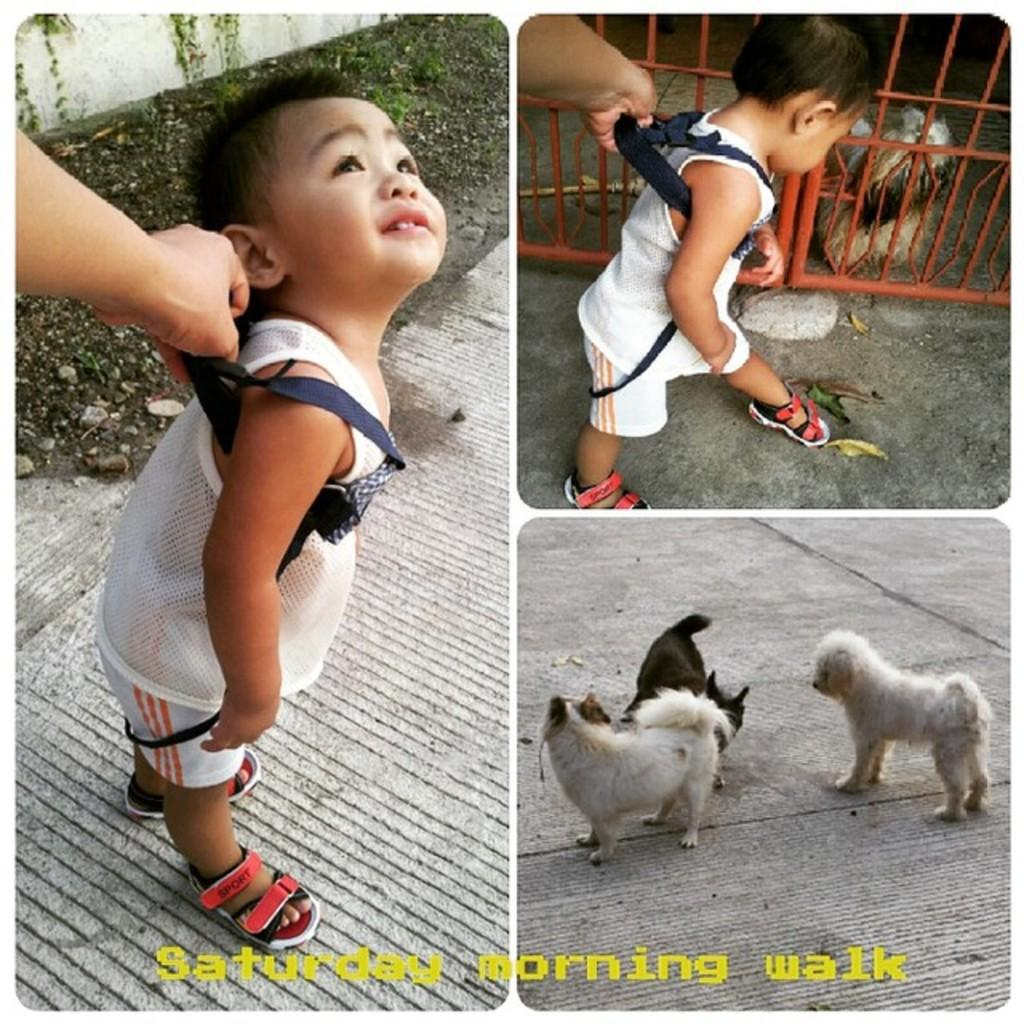What type of picture is in the image? The image contains a collage picture. Who or what can be seen in the collage? There is a boy and animals in the collage. Where are the boy and animals located in the collage? The boy and animals are on the ground in the collage. Can you describe any other elements in the collage? A person's hand is visible, and there is a fence in the collage. Is there any text present in the collage? Yes, there is some text in the collage. What chance does the father have of winning the lottery in the image? There is no mention of a father or a lottery in the image; it contains a collage with a boy, animals, and other elements. 